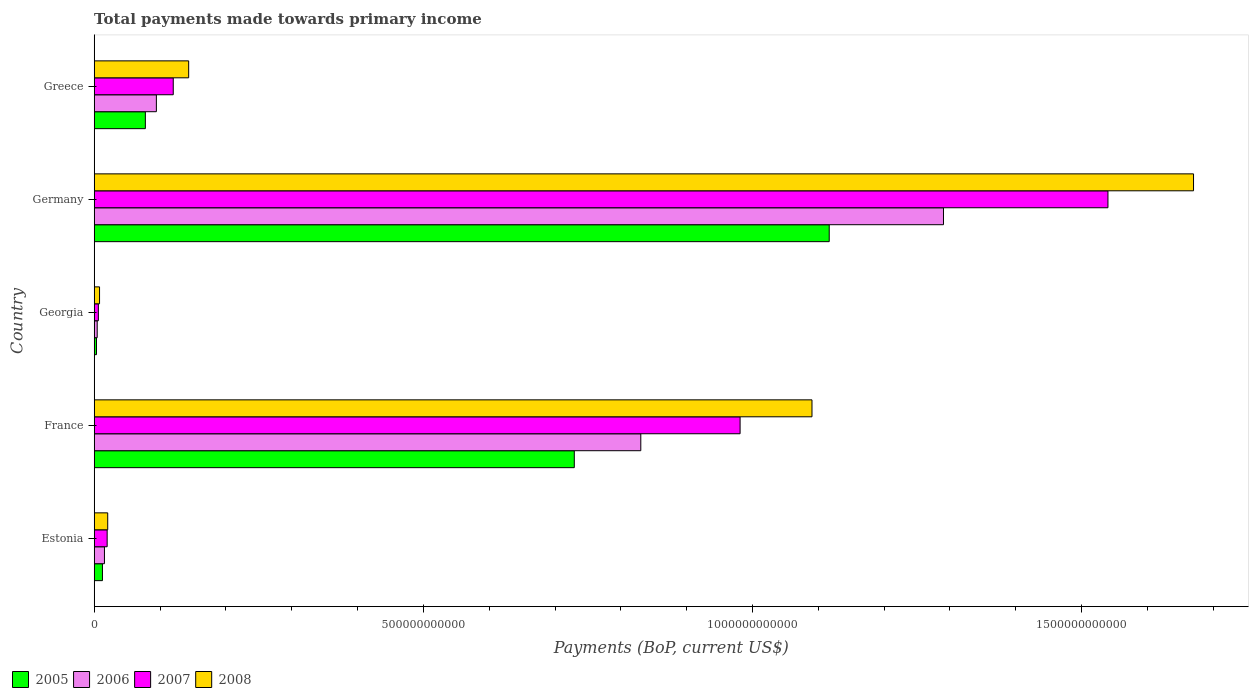How many different coloured bars are there?
Ensure brevity in your answer.  4. Are the number of bars on each tick of the Y-axis equal?
Your answer should be compact. Yes. How many bars are there on the 3rd tick from the top?
Your answer should be very brief. 4. How many bars are there on the 3rd tick from the bottom?
Your answer should be compact. 4. What is the total payments made towards primary income in 2005 in Estonia?
Offer a very short reply. 1.25e+1. Across all countries, what is the maximum total payments made towards primary income in 2008?
Your response must be concise. 1.67e+12. Across all countries, what is the minimum total payments made towards primary income in 2007?
Provide a succinct answer. 6.32e+09. In which country was the total payments made towards primary income in 2008 maximum?
Make the answer very short. Germany. In which country was the total payments made towards primary income in 2008 minimum?
Your response must be concise. Georgia. What is the total total payments made towards primary income in 2007 in the graph?
Provide a succinct answer. 2.67e+12. What is the difference between the total payments made towards primary income in 2006 in Estonia and that in France?
Keep it short and to the point. -8.15e+11. What is the difference between the total payments made towards primary income in 2007 in Germany and the total payments made towards primary income in 2006 in Estonia?
Your answer should be very brief. 1.52e+12. What is the average total payments made towards primary income in 2006 per country?
Make the answer very short. 4.47e+11. What is the difference between the total payments made towards primary income in 2005 and total payments made towards primary income in 2007 in Germany?
Offer a very short reply. -4.23e+11. What is the ratio of the total payments made towards primary income in 2007 in Estonia to that in Georgia?
Your answer should be compact. 3.11. Is the difference between the total payments made towards primary income in 2005 in France and Georgia greater than the difference between the total payments made towards primary income in 2007 in France and Georgia?
Your answer should be compact. No. What is the difference between the highest and the second highest total payments made towards primary income in 2006?
Provide a succinct answer. 4.60e+11. What is the difference between the highest and the lowest total payments made towards primary income in 2006?
Your answer should be very brief. 1.29e+12. Is it the case that in every country, the sum of the total payments made towards primary income in 2006 and total payments made towards primary income in 2005 is greater than the sum of total payments made towards primary income in 2008 and total payments made towards primary income in 2007?
Keep it short and to the point. No. What does the 3rd bar from the bottom in Georgia represents?
Your response must be concise. 2007. Are all the bars in the graph horizontal?
Ensure brevity in your answer.  Yes. How many countries are there in the graph?
Your answer should be compact. 5. What is the difference between two consecutive major ticks on the X-axis?
Offer a very short reply. 5.00e+11. Are the values on the major ticks of X-axis written in scientific E-notation?
Offer a terse response. No. Does the graph contain any zero values?
Give a very brief answer. No. Does the graph contain grids?
Your response must be concise. No. How are the legend labels stacked?
Your response must be concise. Horizontal. What is the title of the graph?
Your answer should be very brief. Total payments made towards primary income. What is the label or title of the X-axis?
Ensure brevity in your answer.  Payments (BoP, current US$). What is the Payments (BoP, current US$) of 2005 in Estonia?
Your answer should be compact. 1.25e+1. What is the Payments (BoP, current US$) in 2006 in Estonia?
Offer a terse response. 1.56e+1. What is the Payments (BoP, current US$) in 2007 in Estonia?
Ensure brevity in your answer.  1.97e+1. What is the Payments (BoP, current US$) in 2008 in Estonia?
Your answer should be very brief. 2.05e+1. What is the Payments (BoP, current US$) in 2005 in France?
Offer a very short reply. 7.29e+11. What is the Payments (BoP, current US$) of 2006 in France?
Your answer should be very brief. 8.30e+11. What is the Payments (BoP, current US$) in 2007 in France?
Your answer should be compact. 9.81e+11. What is the Payments (BoP, current US$) of 2008 in France?
Your answer should be very brief. 1.09e+12. What is the Payments (BoP, current US$) in 2005 in Georgia?
Provide a short and direct response. 3.47e+09. What is the Payments (BoP, current US$) in 2006 in Georgia?
Keep it short and to the point. 4.56e+09. What is the Payments (BoP, current US$) in 2007 in Georgia?
Keep it short and to the point. 6.32e+09. What is the Payments (BoP, current US$) of 2008 in Georgia?
Your answer should be compact. 8.11e+09. What is the Payments (BoP, current US$) in 2005 in Germany?
Give a very brief answer. 1.12e+12. What is the Payments (BoP, current US$) of 2006 in Germany?
Ensure brevity in your answer.  1.29e+12. What is the Payments (BoP, current US$) in 2007 in Germany?
Provide a short and direct response. 1.54e+12. What is the Payments (BoP, current US$) of 2008 in Germany?
Keep it short and to the point. 1.67e+12. What is the Payments (BoP, current US$) of 2005 in Greece?
Your response must be concise. 7.77e+1. What is the Payments (BoP, current US$) in 2006 in Greece?
Your answer should be compact. 9.44e+1. What is the Payments (BoP, current US$) of 2007 in Greece?
Keep it short and to the point. 1.20e+11. What is the Payments (BoP, current US$) of 2008 in Greece?
Make the answer very short. 1.44e+11. Across all countries, what is the maximum Payments (BoP, current US$) of 2005?
Make the answer very short. 1.12e+12. Across all countries, what is the maximum Payments (BoP, current US$) in 2006?
Provide a short and direct response. 1.29e+12. Across all countries, what is the maximum Payments (BoP, current US$) in 2007?
Provide a succinct answer. 1.54e+12. Across all countries, what is the maximum Payments (BoP, current US$) of 2008?
Make the answer very short. 1.67e+12. Across all countries, what is the minimum Payments (BoP, current US$) of 2005?
Your response must be concise. 3.47e+09. Across all countries, what is the minimum Payments (BoP, current US$) in 2006?
Your answer should be compact. 4.56e+09. Across all countries, what is the minimum Payments (BoP, current US$) of 2007?
Offer a terse response. 6.32e+09. Across all countries, what is the minimum Payments (BoP, current US$) of 2008?
Your response must be concise. 8.11e+09. What is the total Payments (BoP, current US$) in 2005 in the graph?
Your response must be concise. 1.94e+12. What is the total Payments (BoP, current US$) in 2006 in the graph?
Your response must be concise. 2.24e+12. What is the total Payments (BoP, current US$) of 2007 in the graph?
Give a very brief answer. 2.67e+12. What is the total Payments (BoP, current US$) of 2008 in the graph?
Your answer should be compact. 2.93e+12. What is the difference between the Payments (BoP, current US$) in 2005 in Estonia and that in France?
Give a very brief answer. -7.17e+11. What is the difference between the Payments (BoP, current US$) in 2006 in Estonia and that in France?
Provide a succinct answer. -8.15e+11. What is the difference between the Payments (BoP, current US$) of 2007 in Estonia and that in France?
Your response must be concise. -9.61e+11. What is the difference between the Payments (BoP, current US$) in 2008 in Estonia and that in France?
Your answer should be very brief. -1.07e+12. What is the difference between the Payments (BoP, current US$) in 2005 in Estonia and that in Georgia?
Your answer should be very brief. 9.08e+09. What is the difference between the Payments (BoP, current US$) of 2006 in Estonia and that in Georgia?
Your answer should be compact. 1.10e+1. What is the difference between the Payments (BoP, current US$) of 2007 in Estonia and that in Georgia?
Keep it short and to the point. 1.34e+1. What is the difference between the Payments (BoP, current US$) of 2008 in Estonia and that in Georgia?
Your answer should be compact. 1.24e+1. What is the difference between the Payments (BoP, current US$) of 2005 in Estonia and that in Germany?
Offer a terse response. -1.10e+12. What is the difference between the Payments (BoP, current US$) of 2006 in Estonia and that in Germany?
Your answer should be compact. -1.27e+12. What is the difference between the Payments (BoP, current US$) in 2007 in Estonia and that in Germany?
Keep it short and to the point. -1.52e+12. What is the difference between the Payments (BoP, current US$) in 2008 in Estonia and that in Germany?
Make the answer very short. -1.65e+12. What is the difference between the Payments (BoP, current US$) of 2005 in Estonia and that in Greece?
Your response must be concise. -6.52e+1. What is the difference between the Payments (BoP, current US$) in 2006 in Estonia and that in Greece?
Keep it short and to the point. -7.89e+1. What is the difference between the Payments (BoP, current US$) of 2007 in Estonia and that in Greece?
Your answer should be very brief. -1.00e+11. What is the difference between the Payments (BoP, current US$) in 2008 in Estonia and that in Greece?
Your answer should be very brief. -1.23e+11. What is the difference between the Payments (BoP, current US$) of 2005 in France and that in Georgia?
Make the answer very short. 7.26e+11. What is the difference between the Payments (BoP, current US$) in 2006 in France and that in Georgia?
Offer a terse response. 8.26e+11. What is the difference between the Payments (BoP, current US$) of 2007 in France and that in Georgia?
Provide a short and direct response. 9.75e+11. What is the difference between the Payments (BoP, current US$) in 2008 in France and that in Georgia?
Offer a very short reply. 1.08e+12. What is the difference between the Payments (BoP, current US$) in 2005 in France and that in Germany?
Your answer should be compact. -3.87e+11. What is the difference between the Payments (BoP, current US$) in 2006 in France and that in Germany?
Provide a succinct answer. -4.60e+11. What is the difference between the Payments (BoP, current US$) in 2007 in France and that in Germany?
Give a very brief answer. -5.59e+11. What is the difference between the Payments (BoP, current US$) in 2008 in France and that in Germany?
Provide a short and direct response. -5.80e+11. What is the difference between the Payments (BoP, current US$) in 2005 in France and that in Greece?
Your response must be concise. 6.52e+11. What is the difference between the Payments (BoP, current US$) in 2006 in France and that in Greece?
Your answer should be compact. 7.36e+11. What is the difference between the Payments (BoP, current US$) of 2007 in France and that in Greece?
Provide a short and direct response. 8.61e+11. What is the difference between the Payments (BoP, current US$) of 2008 in France and that in Greece?
Make the answer very short. 9.47e+11. What is the difference between the Payments (BoP, current US$) of 2005 in Georgia and that in Germany?
Provide a short and direct response. -1.11e+12. What is the difference between the Payments (BoP, current US$) of 2006 in Georgia and that in Germany?
Keep it short and to the point. -1.29e+12. What is the difference between the Payments (BoP, current US$) of 2007 in Georgia and that in Germany?
Provide a succinct answer. -1.53e+12. What is the difference between the Payments (BoP, current US$) in 2008 in Georgia and that in Germany?
Provide a succinct answer. -1.66e+12. What is the difference between the Payments (BoP, current US$) in 2005 in Georgia and that in Greece?
Your answer should be compact. -7.43e+1. What is the difference between the Payments (BoP, current US$) in 2006 in Georgia and that in Greece?
Offer a very short reply. -8.99e+1. What is the difference between the Payments (BoP, current US$) of 2007 in Georgia and that in Greece?
Your answer should be very brief. -1.14e+11. What is the difference between the Payments (BoP, current US$) in 2008 in Georgia and that in Greece?
Ensure brevity in your answer.  -1.35e+11. What is the difference between the Payments (BoP, current US$) of 2005 in Germany and that in Greece?
Offer a terse response. 1.04e+12. What is the difference between the Payments (BoP, current US$) of 2006 in Germany and that in Greece?
Your response must be concise. 1.20e+12. What is the difference between the Payments (BoP, current US$) of 2007 in Germany and that in Greece?
Offer a very short reply. 1.42e+12. What is the difference between the Payments (BoP, current US$) in 2008 in Germany and that in Greece?
Ensure brevity in your answer.  1.53e+12. What is the difference between the Payments (BoP, current US$) of 2005 in Estonia and the Payments (BoP, current US$) of 2006 in France?
Provide a succinct answer. -8.18e+11. What is the difference between the Payments (BoP, current US$) of 2005 in Estonia and the Payments (BoP, current US$) of 2007 in France?
Keep it short and to the point. -9.69e+11. What is the difference between the Payments (BoP, current US$) in 2005 in Estonia and the Payments (BoP, current US$) in 2008 in France?
Provide a short and direct response. -1.08e+12. What is the difference between the Payments (BoP, current US$) of 2006 in Estonia and the Payments (BoP, current US$) of 2007 in France?
Offer a very short reply. -9.66e+11. What is the difference between the Payments (BoP, current US$) in 2006 in Estonia and the Payments (BoP, current US$) in 2008 in France?
Offer a terse response. -1.07e+12. What is the difference between the Payments (BoP, current US$) of 2007 in Estonia and the Payments (BoP, current US$) of 2008 in France?
Your answer should be compact. -1.07e+12. What is the difference between the Payments (BoP, current US$) of 2005 in Estonia and the Payments (BoP, current US$) of 2006 in Georgia?
Your answer should be very brief. 7.99e+09. What is the difference between the Payments (BoP, current US$) in 2005 in Estonia and the Payments (BoP, current US$) in 2007 in Georgia?
Your response must be concise. 6.22e+09. What is the difference between the Payments (BoP, current US$) of 2005 in Estonia and the Payments (BoP, current US$) of 2008 in Georgia?
Ensure brevity in your answer.  4.43e+09. What is the difference between the Payments (BoP, current US$) in 2006 in Estonia and the Payments (BoP, current US$) in 2007 in Georgia?
Your answer should be very brief. 9.25e+09. What is the difference between the Payments (BoP, current US$) of 2006 in Estonia and the Payments (BoP, current US$) of 2008 in Georgia?
Offer a very short reply. 7.46e+09. What is the difference between the Payments (BoP, current US$) in 2007 in Estonia and the Payments (BoP, current US$) in 2008 in Georgia?
Give a very brief answer. 1.16e+1. What is the difference between the Payments (BoP, current US$) of 2005 in Estonia and the Payments (BoP, current US$) of 2006 in Germany?
Your answer should be compact. -1.28e+12. What is the difference between the Payments (BoP, current US$) of 2005 in Estonia and the Payments (BoP, current US$) of 2007 in Germany?
Offer a terse response. -1.53e+12. What is the difference between the Payments (BoP, current US$) in 2005 in Estonia and the Payments (BoP, current US$) in 2008 in Germany?
Your answer should be very brief. -1.66e+12. What is the difference between the Payments (BoP, current US$) of 2006 in Estonia and the Payments (BoP, current US$) of 2007 in Germany?
Your answer should be compact. -1.52e+12. What is the difference between the Payments (BoP, current US$) in 2006 in Estonia and the Payments (BoP, current US$) in 2008 in Germany?
Give a very brief answer. -1.65e+12. What is the difference between the Payments (BoP, current US$) in 2007 in Estonia and the Payments (BoP, current US$) in 2008 in Germany?
Provide a succinct answer. -1.65e+12. What is the difference between the Payments (BoP, current US$) of 2005 in Estonia and the Payments (BoP, current US$) of 2006 in Greece?
Give a very brief answer. -8.19e+1. What is the difference between the Payments (BoP, current US$) in 2005 in Estonia and the Payments (BoP, current US$) in 2007 in Greece?
Ensure brevity in your answer.  -1.08e+11. What is the difference between the Payments (BoP, current US$) of 2005 in Estonia and the Payments (BoP, current US$) of 2008 in Greece?
Give a very brief answer. -1.31e+11. What is the difference between the Payments (BoP, current US$) of 2006 in Estonia and the Payments (BoP, current US$) of 2007 in Greece?
Your response must be concise. -1.05e+11. What is the difference between the Payments (BoP, current US$) of 2006 in Estonia and the Payments (BoP, current US$) of 2008 in Greece?
Your answer should be very brief. -1.28e+11. What is the difference between the Payments (BoP, current US$) in 2007 in Estonia and the Payments (BoP, current US$) in 2008 in Greece?
Your response must be concise. -1.24e+11. What is the difference between the Payments (BoP, current US$) in 2005 in France and the Payments (BoP, current US$) in 2006 in Georgia?
Offer a terse response. 7.25e+11. What is the difference between the Payments (BoP, current US$) in 2005 in France and the Payments (BoP, current US$) in 2007 in Georgia?
Provide a short and direct response. 7.23e+11. What is the difference between the Payments (BoP, current US$) of 2005 in France and the Payments (BoP, current US$) of 2008 in Georgia?
Provide a short and direct response. 7.21e+11. What is the difference between the Payments (BoP, current US$) in 2006 in France and the Payments (BoP, current US$) in 2007 in Georgia?
Offer a very short reply. 8.24e+11. What is the difference between the Payments (BoP, current US$) in 2006 in France and the Payments (BoP, current US$) in 2008 in Georgia?
Make the answer very short. 8.22e+11. What is the difference between the Payments (BoP, current US$) in 2007 in France and the Payments (BoP, current US$) in 2008 in Georgia?
Keep it short and to the point. 9.73e+11. What is the difference between the Payments (BoP, current US$) of 2005 in France and the Payments (BoP, current US$) of 2006 in Germany?
Your answer should be compact. -5.61e+11. What is the difference between the Payments (BoP, current US$) of 2005 in France and the Payments (BoP, current US$) of 2007 in Germany?
Your answer should be compact. -8.11e+11. What is the difference between the Payments (BoP, current US$) of 2005 in France and the Payments (BoP, current US$) of 2008 in Germany?
Provide a short and direct response. -9.41e+11. What is the difference between the Payments (BoP, current US$) of 2006 in France and the Payments (BoP, current US$) of 2007 in Germany?
Ensure brevity in your answer.  -7.10e+11. What is the difference between the Payments (BoP, current US$) of 2006 in France and the Payments (BoP, current US$) of 2008 in Germany?
Offer a terse response. -8.40e+11. What is the difference between the Payments (BoP, current US$) of 2007 in France and the Payments (BoP, current US$) of 2008 in Germany?
Offer a very short reply. -6.89e+11. What is the difference between the Payments (BoP, current US$) of 2005 in France and the Payments (BoP, current US$) of 2006 in Greece?
Offer a terse response. 6.35e+11. What is the difference between the Payments (BoP, current US$) of 2005 in France and the Payments (BoP, current US$) of 2007 in Greece?
Give a very brief answer. 6.09e+11. What is the difference between the Payments (BoP, current US$) of 2005 in France and the Payments (BoP, current US$) of 2008 in Greece?
Provide a succinct answer. 5.86e+11. What is the difference between the Payments (BoP, current US$) in 2006 in France and the Payments (BoP, current US$) in 2007 in Greece?
Offer a terse response. 7.10e+11. What is the difference between the Payments (BoP, current US$) in 2006 in France and the Payments (BoP, current US$) in 2008 in Greece?
Your answer should be compact. 6.87e+11. What is the difference between the Payments (BoP, current US$) in 2007 in France and the Payments (BoP, current US$) in 2008 in Greece?
Provide a succinct answer. 8.38e+11. What is the difference between the Payments (BoP, current US$) in 2005 in Georgia and the Payments (BoP, current US$) in 2006 in Germany?
Your response must be concise. -1.29e+12. What is the difference between the Payments (BoP, current US$) of 2005 in Georgia and the Payments (BoP, current US$) of 2007 in Germany?
Provide a succinct answer. -1.54e+12. What is the difference between the Payments (BoP, current US$) in 2005 in Georgia and the Payments (BoP, current US$) in 2008 in Germany?
Provide a short and direct response. -1.67e+12. What is the difference between the Payments (BoP, current US$) of 2006 in Georgia and the Payments (BoP, current US$) of 2007 in Germany?
Keep it short and to the point. -1.54e+12. What is the difference between the Payments (BoP, current US$) of 2006 in Georgia and the Payments (BoP, current US$) of 2008 in Germany?
Offer a terse response. -1.67e+12. What is the difference between the Payments (BoP, current US$) of 2007 in Georgia and the Payments (BoP, current US$) of 2008 in Germany?
Your response must be concise. -1.66e+12. What is the difference between the Payments (BoP, current US$) of 2005 in Georgia and the Payments (BoP, current US$) of 2006 in Greece?
Your answer should be compact. -9.10e+1. What is the difference between the Payments (BoP, current US$) in 2005 in Georgia and the Payments (BoP, current US$) in 2007 in Greece?
Make the answer very short. -1.17e+11. What is the difference between the Payments (BoP, current US$) of 2005 in Georgia and the Payments (BoP, current US$) of 2008 in Greece?
Provide a succinct answer. -1.40e+11. What is the difference between the Payments (BoP, current US$) in 2006 in Georgia and the Payments (BoP, current US$) in 2007 in Greece?
Offer a terse response. -1.16e+11. What is the difference between the Payments (BoP, current US$) of 2006 in Georgia and the Payments (BoP, current US$) of 2008 in Greece?
Provide a succinct answer. -1.39e+11. What is the difference between the Payments (BoP, current US$) in 2007 in Georgia and the Payments (BoP, current US$) in 2008 in Greece?
Give a very brief answer. -1.37e+11. What is the difference between the Payments (BoP, current US$) in 2005 in Germany and the Payments (BoP, current US$) in 2006 in Greece?
Make the answer very short. 1.02e+12. What is the difference between the Payments (BoP, current US$) of 2005 in Germany and the Payments (BoP, current US$) of 2007 in Greece?
Provide a short and direct response. 9.96e+11. What is the difference between the Payments (BoP, current US$) in 2005 in Germany and the Payments (BoP, current US$) in 2008 in Greece?
Provide a short and direct response. 9.73e+11. What is the difference between the Payments (BoP, current US$) of 2006 in Germany and the Payments (BoP, current US$) of 2007 in Greece?
Ensure brevity in your answer.  1.17e+12. What is the difference between the Payments (BoP, current US$) of 2006 in Germany and the Payments (BoP, current US$) of 2008 in Greece?
Provide a succinct answer. 1.15e+12. What is the difference between the Payments (BoP, current US$) of 2007 in Germany and the Payments (BoP, current US$) of 2008 in Greece?
Keep it short and to the point. 1.40e+12. What is the average Payments (BoP, current US$) in 2005 per country?
Make the answer very short. 3.88e+11. What is the average Payments (BoP, current US$) in 2006 per country?
Keep it short and to the point. 4.47e+11. What is the average Payments (BoP, current US$) of 2007 per country?
Your answer should be compact. 5.33e+11. What is the average Payments (BoP, current US$) in 2008 per country?
Your answer should be compact. 5.86e+11. What is the difference between the Payments (BoP, current US$) of 2005 and Payments (BoP, current US$) of 2006 in Estonia?
Your response must be concise. -3.02e+09. What is the difference between the Payments (BoP, current US$) in 2005 and Payments (BoP, current US$) in 2007 in Estonia?
Offer a very short reply. -7.14e+09. What is the difference between the Payments (BoP, current US$) of 2005 and Payments (BoP, current US$) of 2008 in Estonia?
Your answer should be compact. -7.98e+09. What is the difference between the Payments (BoP, current US$) of 2006 and Payments (BoP, current US$) of 2007 in Estonia?
Your answer should be very brief. -4.11e+09. What is the difference between the Payments (BoP, current US$) in 2006 and Payments (BoP, current US$) in 2008 in Estonia?
Provide a succinct answer. -4.96e+09. What is the difference between the Payments (BoP, current US$) of 2007 and Payments (BoP, current US$) of 2008 in Estonia?
Give a very brief answer. -8.45e+08. What is the difference between the Payments (BoP, current US$) of 2005 and Payments (BoP, current US$) of 2006 in France?
Give a very brief answer. -1.01e+11. What is the difference between the Payments (BoP, current US$) in 2005 and Payments (BoP, current US$) in 2007 in France?
Your answer should be very brief. -2.52e+11. What is the difference between the Payments (BoP, current US$) of 2005 and Payments (BoP, current US$) of 2008 in France?
Keep it short and to the point. -3.61e+11. What is the difference between the Payments (BoP, current US$) in 2006 and Payments (BoP, current US$) in 2007 in France?
Provide a succinct answer. -1.51e+11. What is the difference between the Payments (BoP, current US$) in 2006 and Payments (BoP, current US$) in 2008 in France?
Offer a terse response. -2.60e+11. What is the difference between the Payments (BoP, current US$) in 2007 and Payments (BoP, current US$) in 2008 in France?
Your answer should be very brief. -1.09e+11. What is the difference between the Payments (BoP, current US$) in 2005 and Payments (BoP, current US$) in 2006 in Georgia?
Your answer should be compact. -1.09e+09. What is the difference between the Payments (BoP, current US$) in 2005 and Payments (BoP, current US$) in 2007 in Georgia?
Your answer should be very brief. -2.86e+09. What is the difference between the Payments (BoP, current US$) of 2005 and Payments (BoP, current US$) of 2008 in Georgia?
Give a very brief answer. -4.65e+09. What is the difference between the Payments (BoP, current US$) of 2006 and Payments (BoP, current US$) of 2007 in Georgia?
Your response must be concise. -1.77e+09. What is the difference between the Payments (BoP, current US$) in 2006 and Payments (BoP, current US$) in 2008 in Georgia?
Give a very brief answer. -3.56e+09. What is the difference between the Payments (BoP, current US$) of 2007 and Payments (BoP, current US$) of 2008 in Georgia?
Offer a very short reply. -1.79e+09. What is the difference between the Payments (BoP, current US$) in 2005 and Payments (BoP, current US$) in 2006 in Germany?
Keep it short and to the point. -1.74e+11. What is the difference between the Payments (BoP, current US$) of 2005 and Payments (BoP, current US$) of 2007 in Germany?
Ensure brevity in your answer.  -4.23e+11. What is the difference between the Payments (BoP, current US$) of 2005 and Payments (BoP, current US$) of 2008 in Germany?
Your answer should be compact. -5.53e+11. What is the difference between the Payments (BoP, current US$) of 2006 and Payments (BoP, current US$) of 2007 in Germany?
Your response must be concise. -2.50e+11. What is the difference between the Payments (BoP, current US$) in 2006 and Payments (BoP, current US$) in 2008 in Germany?
Offer a terse response. -3.80e+11. What is the difference between the Payments (BoP, current US$) in 2007 and Payments (BoP, current US$) in 2008 in Germany?
Your answer should be compact. -1.30e+11. What is the difference between the Payments (BoP, current US$) in 2005 and Payments (BoP, current US$) in 2006 in Greece?
Keep it short and to the point. -1.67e+1. What is the difference between the Payments (BoP, current US$) in 2005 and Payments (BoP, current US$) in 2007 in Greece?
Make the answer very short. -4.24e+1. What is the difference between the Payments (BoP, current US$) in 2005 and Payments (BoP, current US$) in 2008 in Greece?
Ensure brevity in your answer.  -6.58e+1. What is the difference between the Payments (BoP, current US$) in 2006 and Payments (BoP, current US$) in 2007 in Greece?
Offer a terse response. -2.56e+1. What is the difference between the Payments (BoP, current US$) of 2006 and Payments (BoP, current US$) of 2008 in Greece?
Give a very brief answer. -4.91e+1. What is the difference between the Payments (BoP, current US$) of 2007 and Payments (BoP, current US$) of 2008 in Greece?
Give a very brief answer. -2.34e+1. What is the ratio of the Payments (BoP, current US$) of 2005 in Estonia to that in France?
Your answer should be compact. 0.02. What is the ratio of the Payments (BoP, current US$) of 2006 in Estonia to that in France?
Provide a succinct answer. 0.02. What is the ratio of the Payments (BoP, current US$) of 2007 in Estonia to that in France?
Give a very brief answer. 0.02. What is the ratio of the Payments (BoP, current US$) in 2008 in Estonia to that in France?
Make the answer very short. 0.02. What is the ratio of the Payments (BoP, current US$) of 2005 in Estonia to that in Georgia?
Provide a succinct answer. 3.62. What is the ratio of the Payments (BoP, current US$) of 2006 in Estonia to that in Georgia?
Offer a very short reply. 3.42. What is the ratio of the Payments (BoP, current US$) in 2007 in Estonia to that in Georgia?
Make the answer very short. 3.11. What is the ratio of the Payments (BoP, current US$) of 2008 in Estonia to that in Georgia?
Make the answer very short. 2.53. What is the ratio of the Payments (BoP, current US$) of 2005 in Estonia to that in Germany?
Provide a succinct answer. 0.01. What is the ratio of the Payments (BoP, current US$) in 2006 in Estonia to that in Germany?
Offer a very short reply. 0.01. What is the ratio of the Payments (BoP, current US$) of 2007 in Estonia to that in Germany?
Make the answer very short. 0.01. What is the ratio of the Payments (BoP, current US$) in 2008 in Estonia to that in Germany?
Keep it short and to the point. 0.01. What is the ratio of the Payments (BoP, current US$) of 2005 in Estonia to that in Greece?
Offer a terse response. 0.16. What is the ratio of the Payments (BoP, current US$) in 2006 in Estonia to that in Greece?
Offer a very short reply. 0.16. What is the ratio of the Payments (BoP, current US$) of 2007 in Estonia to that in Greece?
Provide a short and direct response. 0.16. What is the ratio of the Payments (BoP, current US$) in 2008 in Estonia to that in Greece?
Provide a short and direct response. 0.14. What is the ratio of the Payments (BoP, current US$) in 2005 in France to that in Georgia?
Offer a very short reply. 210.24. What is the ratio of the Payments (BoP, current US$) of 2006 in France to that in Georgia?
Your answer should be very brief. 182.27. What is the ratio of the Payments (BoP, current US$) of 2007 in France to that in Georgia?
Your response must be concise. 155.13. What is the ratio of the Payments (BoP, current US$) in 2008 in France to that in Georgia?
Your answer should be very brief. 134.37. What is the ratio of the Payments (BoP, current US$) of 2005 in France to that in Germany?
Your answer should be compact. 0.65. What is the ratio of the Payments (BoP, current US$) of 2006 in France to that in Germany?
Ensure brevity in your answer.  0.64. What is the ratio of the Payments (BoP, current US$) in 2007 in France to that in Germany?
Give a very brief answer. 0.64. What is the ratio of the Payments (BoP, current US$) of 2008 in France to that in Germany?
Offer a very short reply. 0.65. What is the ratio of the Payments (BoP, current US$) of 2005 in France to that in Greece?
Keep it short and to the point. 9.38. What is the ratio of the Payments (BoP, current US$) in 2006 in France to that in Greece?
Ensure brevity in your answer.  8.79. What is the ratio of the Payments (BoP, current US$) in 2007 in France to that in Greece?
Keep it short and to the point. 8.17. What is the ratio of the Payments (BoP, current US$) in 2008 in France to that in Greece?
Your response must be concise. 7.6. What is the ratio of the Payments (BoP, current US$) of 2005 in Georgia to that in Germany?
Make the answer very short. 0. What is the ratio of the Payments (BoP, current US$) in 2006 in Georgia to that in Germany?
Your answer should be compact. 0. What is the ratio of the Payments (BoP, current US$) in 2007 in Georgia to that in Germany?
Offer a very short reply. 0. What is the ratio of the Payments (BoP, current US$) of 2008 in Georgia to that in Germany?
Give a very brief answer. 0. What is the ratio of the Payments (BoP, current US$) of 2005 in Georgia to that in Greece?
Ensure brevity in your answer.  0.04. What is the ratio of the Payments (BoP, current US$) of 2006 in Georgia to that in Greece?
Provide a succinct answer. 0.05. What is the ratio of the Payments (BoP, current US$) of 2007 in Georgia to that in Greece?
Keep it short and to the point. 0.05. What is the ratio of the Payments (BoP, current US$) in 2008 in Georgia to that in Greece?
Make the answer very short. 0.06. What is the ratio of the Payments (BoP, current US$) in 2005 in Germany to that in Greece?
Ensure brevity in your answer.  14.37. What is the ratio of the Payments (BoP, current US$) of 2006 in Germany to that in Greece?
Ensure brevity in your answer.  13.66. What is the ratio of the Payments (BoP, current US$) in 2007 in Germany to that in Greece?
Offer a very short reply. 12.82. What is the ratio of the Payments (BoP, current US$) of 2008 in Germany to that in Greece?
Your answer should be compact. 11.64. What is the difference between the highest and the second highest Payments (BoP, current US$) in 2005?
Your response must be concise. 3.87e+11. What is the difference between the highest and the second highest Payments (BoP, current US$) in 2006?
Your answer should be very brief. 4.60e+11. What is the difference between the highest and the second highest Payments (BoP, current US$) of 2007?
Give a very brief answer. 5.59e+11. What is the difference between the highest and the second highest Payments (BoP, current US$) in 2008?
Offer a terse response. 5.80e+11. What is the difference between the highest and the lowest Payments (BoP, current US$) of 2005?
Offer a terse response. 1.11e+12. What is the difference between the highest and the lowest Payments (BoP, current US$) of 2006?
Make the answer very short. 1.29e+12. What is the difference between the highest and the lowest Payments (BoP, current US$) of 2007?
Provide a short and direct response. 1.53e+12. What is the difference between the highest and the lowest Payments (BoP, current US$) in 2008?
Offer a terse response. 1.66e+12. 